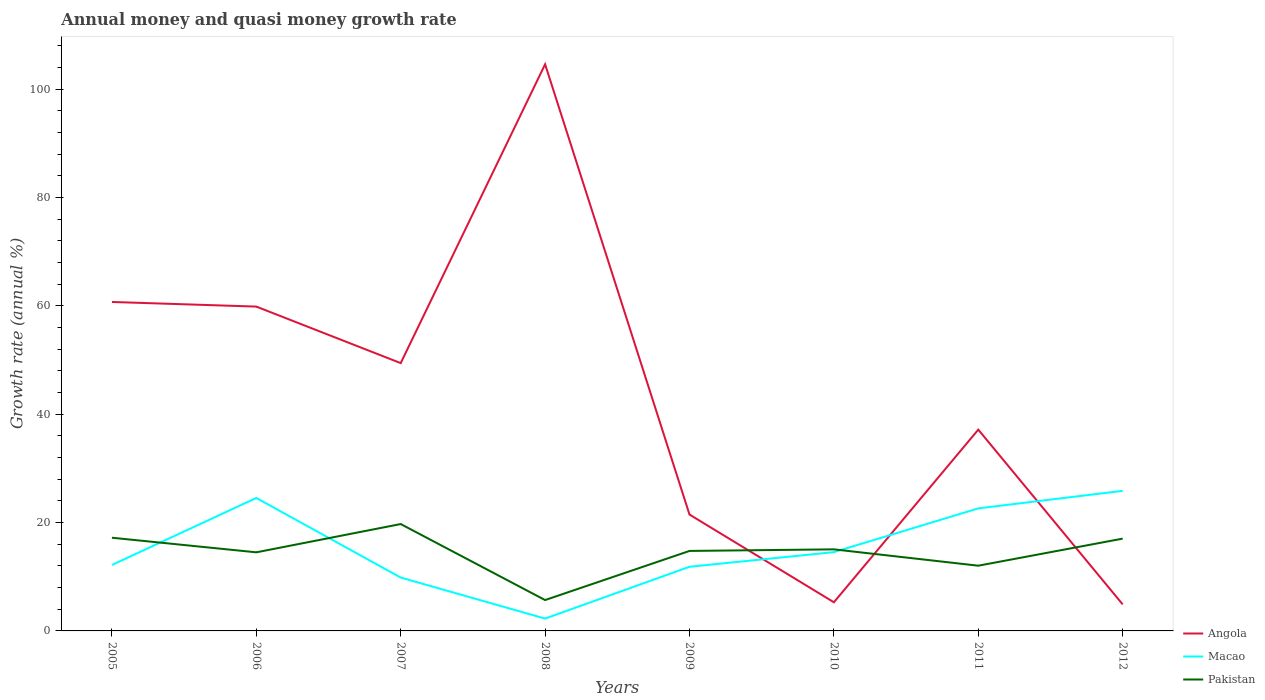Does the line corresponding to Macao intersect with the line corresponding to Pakistan?
Your answer should be compact. Yes. Is the number of lines equal to the number of legend labels?
Offer a terse response. Yes. Across all years, what is the maximum growth rate in Angola?
Your answer should be very brief. 4.9. In which year was the growth rate in Macao maximum?
Offer a very short reply. 2008. What is the total growth rate in Angola in the graph?
Provide a succinct answer. 10.43. What is the difference between the highest and the second highest growth rate in Pakistan?
Provide a short and direct response. 14.03. What is the difference between the highest and the lowest growth rate in Angola?
Ensure brevity in your answer.  4. Is the growth rate in Macao strictly greater than the growth rate in Angola over the years?
Your response must be concise. No. How many lines are there?
Your answer should be compact. 3. What is the difference between two consecutive major ticks on the Y-axis?
Provide a short and direct response. 20. Are the values on the major ticks of Y-axis written in scientific E-notation?
Offer a very short reply. No. What is the title of the graph?
Your answer should be compact. Annual money and quasi money growth rate. Does "Zambia" appear as one of the legend labels in the graph?
Keep it short and to the point. No. What is the label or title of the X-axis?
Keep it short and to the point. Years. What is the label or title of the Y-axis?
Your response must be concise. Growth rate (annual %). What is the Growth rate (annual %) of Angola in 2005?
Provide a succinct answer. 60.71. What is the Growth rate (annual %) of Macao in 2005?
Give a very brief answer. 12.17. What is the Growth rate (annual %) of Pakistan in 2005?
Ensure brevity in your answer.  17.2. What is the Growth rate (annual %) in Angola in 2006?
Your answer should be compact. 59.85. What is the Growth rate (annual %) of Macao in 2006?
Provide a succinct answer. 24.54. What is the Growth rate (annual %) of Pakistan in 2006?
Your answer should be very brief. 14.5. What is the Growth rate (annual %) of Angola in 2007?
Offer a very short reply. 49.42. What is the Growth rate (annual %) of Macao in 2007?
Offer a very short reply. 9.85. What is the Growth rate (annual %) in Pakistan in 2007?
Your answer should be very brief. 19.72. What is the Growth rate (annual %) in Angola in 2008?
Offer a very short reply. 104.57. What is the Growth rate (annual %) in Macao in 2008?
Your response must be concise. 2.28. What is the Growth rate (annual %) of Pakistan in 2008?
Provide a succinct answer. 5.69. What is the Growth rate (annual %) of Angola in 2009?
Your answer should be compact. 21.48. What is the Growth rate (annual %) of Macao in 2009?
Your answer should be compact. 11.84. What is the Growth rate (annual %) in Pakistan in 2009?
Give a very brief answer. 14.76. What is the Growth rate (annual %) of Angola in 2010?
Give a very brief answer. 5.29. What is the Growth rate (annual %) of Macao in 2010?
Provide a short and direct response. 14.54. What is the Growth rate (annual %) of Pakistan in 2010?
Keep it short and to the point. 15.05. What is the Growth rate (annual %) of Angola in 2011?
Your response must be concise. 37.15. What is the Growth rate (annual %) of Macao in 2011?
Offer a very short reply. 22.61. What is the Growth rate (annual %) in Pakistan in 2011?
Provide a short and direct response. 12.04. What is the Growth rate (annual %) of Angola in 2012?
Keep it short and to the point. 4.9. What is the Growth rate (annual %) of Macao in 2012?
Your answer should be compact. 25.85. What is the Growth rate (annual %) in Pakistan in 2012?
Make the answer very short. 17.03. Across all years, what is the maximum Growth rate (annual %) in Angola?
Ensure brevity in your answer.  104.57. Across all years, what is the maximum Growth rate (annual %) of Macao?
Ensure brevity in your answer.  25.85. Across all years, what is the maximum Growth rate (annual %) in Pakistan?
Provide a succinct answer. 19.72. Across all years, what is the minimum Growth rate (annual %) in Angola?
Provide a succinct answer. 4.9. Across all years, what is the minimum Growth rate (annual %) in Macao?
Make the answer very short. 2.28. Across all years, what is the minimum Growth rate (annual %) of Pakistan?
Keep it short and to the point. 5.69. What is the total Growth rate (annual %) of Angola in the graph?
Make the answer very short. 343.35. What is the total Growth rate (annual %) in Macao in the graph?
Your response must be concise. 123.68. What is the total Growth rate (annual %) of Pakistan in the graph?
Offer a terse response. 116. What is the difference between the Growth rate (annual %) in Angola in 2005 and that in 2006?
Provide a short and direct response. 0.86. What is the difference between the Growth rate (annual %) of Macao in 2005 and that in 2006?
Offer a very short reply. -12.37. What is the difference between the Growth rate (annual %) of Pakistan in 2005 and that in 2006?
Keep it short and to the point. 2.69. What is the difference between the Growth rate (annual %) in Angola in 2005 and that in 2007?
Your answer should be compact. 11.28. What is the difference between the Growth rate (annual %) of Macao in 2005 and that in 2007?
Your answer should be compact. 2.32. What is the difference between the Growth rate (annual %) of Pakistan in 2005 and that in 2007?
Your answer should be compact. -2.52. What is the difference between the Growth rate (annual %) of Angola in 2005 and that in 2008?
Provide a succinct answer. -43.86. What is the difference between the Growth rate (annual %) of Macao in 2005 and that in 2008?
Keep it short and to the point. 9.89. What is the difference between the Growth rate (annual %) of Pakistan in 2005 and that in 2008?
Provide a short and direct response. 11.5. What is the difference between the Growth rate (annual %) in Angola in 2005 and that in 2009?
Your answer should be compact. 39.23. What is the difference between the Growth rate (annual %) of Macao in 2005 and that in 2009?
Ensure brevity in your answer.  0.33. What is the difference between the Growth rate (annual %) of Pakistan in 2005 and that in 2009?
Provide a succinct answer. 2.44. What is the difference between the Growth rate (annual %) in Angola in 2005 and that in 2010?
Ensure brevity in your answer.  55.42. What is the difference between the Growth rate (annual %) in Macao in 2005 and that in 2010?
Provide a short and direct response. -2.37. What is the difference between the Growth rate (annual %) of Pakistan in 2005 and that in 2010?
Provide a short and direct response. 2.14. What is the difference between the Growth rate (annual %) in Angola in 2005 and that in 2011?
Make the answer very short. 23.56. What is the difference between the Growth rate (annual %) of Macao in 2005 and that in 2011?
Keep it short and to the point. -10.44. What is the difference between the Growth rate (annual %) in Pakistan in 2005 and that in 2011?
Provide a short and direct response. 5.16. What is the difference between the Growth rate (annual %) of Angola in 2005 and that in 2012?
Give a very brief answer. 55.81. What is the difference between the Growth rate (annual %) of Macao in 2005 and that in 2012?
Provide a short and direct response. -13.68. What is the difference between the Growth rate (annual %) in Pakistan in 2005 and that in 2012?
Ensure brevity in your answer.  0.17. What is the difference between the Growth rate (annual %) in Angola in 2006 and that in 2007?
Provide a succinct answer. 10.43. What is the difference between the Growth rate (annual %) in Macao in 2006 and that in 2007?
Provide a short and direct response. 14.69. What is the difference between the Growth rate (annual %) in Pakistan in 2006 and that in 2007?
Your answer should be compact. -5.22. What is the difference between the Growth rate (annual %) of Angola in 2006 and that in 2008?
Provide a short and direct response. -44.72. What is the difference between the Growth rate (annual %) of Macao in 2006 and that in 2008?
Keep it short and to the point. 22.26. What is the difference between the Growth rate (annual %) in Pakistan in 2006 and that in 2008?
Offer a very short reply. 8.81. What is the difference between the Growth rate (annual %) of Angola in 2006 and that in 2009?
Give a very brief answer. 38.38. What is the difference between the Growth rate (annual %) in Macao in 2006 and that in 2009?
Give a very brief answer. 12.7. What is the difference between the Growth rate (annual %) of Pakistan in 2006 and that in 2009?
Make the answer very short. -0.25. What is the difference between the Growth rate (annual %) in Angola in 2006 and that in 2010?
Make the answer very short. 54.56. What is the difference between the Growth rate (annual %) of Macao in 2006 and that in 2010?
Your answer should be very brief. 10. What is the difference between the Growth rate (annual %) of Pakistan in 2006 and that in 2010?
Give a very brief answer. -0.55. What is the difference between the Growth rate (annual %) in Angola in 2006 and that in 2011?
Your response must be concise. 22.7. What is the difference between the Growth rate (annual %) in Macao in 2006 and that in 2011?
Make the answer very short. 1.92. What is the difference between the Growth rate (annual %) of Pakistan in 2006 and that in 2011?
Your response must be concise. 2.47. What is the difference between the Growth rate (annual %) of Angola in 2006 and that in 2012?
Ensure brevity in your answer.  54.95. What is the difference between the Growth rate (annual %) of Macao in 2006 and that in 2012?
Offer a very short reply. -1.31. What is the difference between the Growth rate (annual %) of Pakistan in 2006 and that in 2012?
Offer a very short reply. -2.52. What is the difference between the Growth rate (annual %) in Angola in 2007 and that in 2008?
Your answer should be very brief. -55.14. What is the difference between the Growth rate (annual %) in Macao in 2007 and that in 2008?
Your answer should be compact. 7.57. What is the difference between the Growth rate (annual %) in Pakistan in 2007 and that in 2008?
Give a very brief answer. 14.03. What is the difference between the Growth rate (annual %) of Angola in 2007 and that in 2009?
Keep it short and to the point. 27.95. What is the difference between the Growth rate (annual %) in Macao in 2007 and that in 2009?
Your answer should be very brief. -1.99. What is the difference between the Growth rate (annual %) in Pakistan in 2007 and that in 2009?
Your response must be concise. 4.96. What is the difference between the Growth rate (annual %) in Angola in 2007 and that in 2010?
Make the answer very short. 44.13. What is the difference between the Growth rate (annual %) in Macao in 2007 and that in 2010?
Give a very brief answer. -4.69. What is the difference between the Growth rate (annual %) in Pakistan in 2007 and that in 2010?
Ensure brevity in your answer.  4.67. What is the difference between the Growth rate (annual %) in Angola in 2007 and that in 2011?
Provide a succinct answer. 12.27. What is the difference between the Growth rate (annual %) in Macao in 2007 and that in 2011?
Give a very brief answer. -12.76. What is the difference between the Growth rate (annual %) of Pakistan in 2007 and that in 2011?
Your response must be concise. 7.69. What is the difference between the Growth rate (annual %) of Angola in 2007 and that in 2012?
Your answer should be compact. 44.52. What is the difference between the Growth rate (annual %) in Macao in 2007 and that in 2012?
Your answer should be very brief. -16. What is the difference between the Growth rate (annual %) of Pakistan in 2007 and that in 2012?
Your response must be concise. 2.69. What is the difference between the Growth rate (annual %) of Angola in 2008 and that in 2009?
Your answer should be very brief. 83.09. What is the difference between the Growth rate (annual %) in Macao in 2008 and that in 2009?
Keep it short and to the point. -9.56. What is the difference between the Growth rate (annual %) of Pakistan in 2008 and that in 2009?
Ensure brevity in your answer.  -9.06. What is the difference between the Growth rate (annual %) of Angola in 2008 and that in 2010?
Provide a short and direct response. 99.28. What is the difference between the Growth rate (annual %) of Macao in 2008 and that in 2010?
Offer a very short reply. -12.26. What is the difference between the Growth rate (annual %) in Pakistan in 2008 and that in 2010?
Provide a short and direct response. -9.36. What is the difference between the Growth rate (annual %) in Angola in 2008 and that in 2011?
Your answer should be very brief. 67.42. What is the difference between the Growth rate (annual %) in Macao in 2008 and that in 2011?
Provide a succinct answer. -20.34. What is the difference between the Growth rate (annual %) of Pakistan in 2008 and that in 2011?
Your response must be concise. -6.34. What is the difference between the Growth rate (annual %) of Angola in 2008 and that in 2012?
Offer a very short reply. 99.67. What is the difference between the Growth rate (annual %) in Macao in 2008 and that in 2012?
Offer a very short reply. -23.57. What is the difference between the Growth rate (annual %) in Pakistan in 2008 and that in 2012?
Provide a short and direct response. -11.33. What is the difference between the Growth rate (annual %) of Angola in 2009 and that in 2010?
Make the answer very short. 16.19. What is the difference between the Growth rate (annual %) of Macao in 2009 and that in 2010?
Ensure brevity in your answer.  -2.7. What is the difference between the Growth rate (annual %) of Pakistan in 2009 and that in 2010?
Your answer should be very brief. -0.29. What is the difference between the Growth rate (annual %) in Angola in 2009 and that in 2011?
Offer a very short reply. -15.67. What is the difference between the Growth rate (annual %) of Macao in 2009 and that in 2011?
Offer a very short reply. -10.77. What is the difference between the Growth rate (annual %) in Pakistan in 2009 and that in 2011?
Offer a very short reply. 2.72. What is the difference between the Growth rate (annual %) in Angola in 2009 and that in 2012?
Offer a very short reply. 16.58. What is the difference between the Growth rate (annual %) in Macao in 2009 and that in 2012?
Keep it short and to the point. -14.01. What is the difference between the Growth rate (annual %) in Pakistan in 2009 and that in 2012?
Provide a short and direct response. -2.27. What is the difference between the Growth rate (annual %) of Angola in 2010 and that in 2011?
Your answer should be very brief. -31.86. What is the difference between the Growth rate (annual %) in Macao in 2010 and that in 2011?
Your answer should be compact. -8.07. What is the difference between the Growth rate (annual %) of Pakistan in 2010 and that in 2011?
Offer a terse response. 3.02. What is the difference between the Growth rate (annual %) of Angola in 2010 and that in 2012?
Make the answer very short. 0.39. What is the difference between the Growth rate (annual %) in Macao in 2010 and that in 2012?
Provide a short and direct response. -11.31. What is the difference between the Growth rate (annual %) in Pakistan in 2010 and that in 2012?
Offer a terse response. -1.98. What is the difference between the Growth rate (annual %) of Angola in 2011 and that in 2012?
Offer a very short reply. 32.25. What is the difference between the Growth rate (annual %) of Macao in 2011 and that in 2012?
Make the answer very short. -3.24. What is the difference between the Growth rate (annual %) of Pakistan in 2011 and that in 2012?
Your response must be concise. -4.99. What is the difference between the Growth rate (annual %) in Angola in 2005 and the Growth rate (annual %) in Macao in 2006?
Offer a terse response. 36.17. What is the difference between the Growth rate (annual %) in Angola in 2005 and the Growth rate (annual %) in Pakistan in 2006?
Your answer should be very brief. 46.2. What is the difference between the Growth rate (annual %) of Macao in 2005 and the Growth rate (annual %) of Pakistan in 2006?
Offer a terse response. -2.33. What is the difference between the Growth rate (annual %) of Angola in 2005 and the Growth rate (annual %) of Macao in 2007?
Your response must be concise. 50.86. What is the difference between the Growth rate (annual %) in Angola in 2005 and the Growth rate (annual %) in Pakistan in 2007?
Make the answer very short. 40.98. What is the difference between the Growth rate (annual %) of Macao in 2005 and the Growth rate (annual %) of Pakistan in 2007?
Offer a very short reply. -7.55. What is the difference between the Growth rate (annual %) in Angola in 2005 and the Growth rate (annual %) in Macao in 2008?
Offer a terse response. 58.43. What is the difference between the Growth rate (annual %) in Angola in 2005 and the Growth rate (annual %) in Pakistan in 2008?
Offer a terse response. 55.01. What is the difference between the Growth rate (annual %) of Macao in 2005 and the Growth rate (annual %) of Pakistan in 2008?
Ensure brevity in your answer.  6.48. What is the difference between the Growth rate (annual %) in Angola in 2005 and the Growth rate (annual %) in Macao in 2009?
Provide a short and direct response. 48.87. What is the difference between the Growth rate (annual %) of Angola in 2005 and the Growth rate (annual %) of Pakistan in 2009?
Offer a terse response. 45.95. What is the difference between the Growth rate (annual %) of Macao in 2005 and the Growth rate (annual %) of Pakistan in 2009?
Offer a terse response. -2.59. What is the difference between the Growth rate (annual %) in Angola in 2005 and the Growth rate (annual %) in Macao in 2010?
Make the answer very short. 46.17. What is the difference between the Growth rate (annual %) of Angola in 2005 and the Growth rate (annual %) of Pakistan in 2010?
Your answer should be compact. 45.65. What is the difference between the Growth rate (annual %) of Macao in 2005 and the Growth rate (annual %) of Pakistan in 2010?
Your answer should be compact. -2.88. What is the difference between the Growth rate (annual %) of Angola in 2005 and the Growth rate (annual %) of Macao in 2011?
Ensure brevity in your answer.  38.09. What is the difference between the Growth rate (annual %) in Angola in 2005 and the Growth rate (annual %) in Pakistan in 2011?
Provide a short and direct response. 48.67. What is the difference between the Growth rate (annual %) in Macao in 2005 and the Growth rate (annual %) in Pakistan in 2011?
Ensure brevity in your answer.  0.13. What is the difference between the Growth rate (annual %) of Angola in 2005 and the Growth rate (annual %) of Macao in 2012?
Give a very brief answer. 34.85. What is the difference between the Growth rate (annual %) in Angola in 2005 and the Growth rate (annual %) in Pakistan in 2012?
Ensure brevity in your answer.  43.68. What is the difference between the Growth rate (annual %) of Macao in 2005 and the Growth rate (annual %) of Pakistan in 2012?
Your response must be concise. -4.86. What is the difference between the Growth rate (annual %) in Angola in 2006 and the Growth rate (annual %) in Macao in 2007?
Provide a succinct answer. 50. What is the difference between the Growth rate (annual %) of Angola in 2006 and the Growth rate (annual %) of Pakistan in 2007?
Give a very brief answer. 40.13. What is the difference between the Growth rate (annual %) in Macao in 2006 and the Growth rate (annual %) in Pakistan in 2007?
Offer a terse response. 4.81. What is the difference between the Growth rate (annual %) in Angola in 2006 and the Growth rate (annual %) in Macao in 2008?
Your answer should be compact. 57.57. What is the difference between the Growth rate (annual %) of Angola in 2006 and the Growth rate (annual %) of Pakistan in 2008?
Make the answer very short. 54.16. What is the difference between the Growth rate (annual %) in Macao in 2006 and the Growth rate (annual %) in Pakistan in 2008?
Make the answer very short. 18.84. What is the difference between the Growth rate (annual %) of Angola in 2006 and the Growth rate (annual %) of Macao in 2009?
Make the answer very short. 48.01. What is the difference between the Growth rate (annual %) in Angola in 2006 and the Growth rate (annual %) in Pakistan in 2009?
Offer a very short reply. 45.09. What is the difference between the Growth rate (annual %) in Macao in 2006 and the Growth rate (annual %) in Pakistan in 2009?
Offer a terse response. 9.78. What is the difference between the Growth rate (annual %) of Angola in 2006 and the Growth rate (annual %) of Macao in 2010?
Offer a very short reply. 45.31. What is the difference between the Growth rate (annual %) of Angola in 2006 and the Growth rate (annual %) of Pakistan in 2010?
Your response must be concise. 44.8. What is the difference between the Growth rate (annual %) of Macao in 2006 and the Growth rate (annual %) of Pakistan in 2010?
Provide a short and direct response. 9.48. What is the difference between the Growth rate (annual %) in Angola in 2006 and the Growth rate (annual %) in Macao in 2011?
Your answer should be very brief. 37.24. What is the difference between the Growth rate (annual %) of Angola in 2006 and the Growth rate (annual %) of Pakistan in 2011?
Your response must be concise. 47.81. What is the difference between the Growth rate (annual %) in Angola in 2006 and the Growth rate (annual %) in Macao in 2012?
Keep it short and to the point. 34. What is the difference between the Growth rate (annual %) in Angola in 2006 and the Growth rate (annual %) in Pakistan in 2012?
Your response must be concise. 42.82. What is the difference between the Growth rate (annual %) of Macao in 2006 and the Growth rate (annual %) of Pakistan in 2012?
Provide a succinct answer. 7.51. What is the difference between the Growth rate (annual %) of Angola in 2007 and the Growth rate (annual %) of Macao in 2008?
Your response must be concise. 47.14. What is the difference between the Growth rate (annual %) in Angola in 2007 and the Growth rate (annual %) in Pakistan in 2008?
Provide a short and direct response. 43.73. What is the difference between the Growth rate (annual %) of Macao in 2007 and the Growth rate (annual %) of Pakistan in 2008?
Keep it short and to the point. 4.15. What is the difference between the Growth rate (annual %) of Angola in 2007 and the Growth rate (annual %) of Macao in 2009?
Offer a terse response. 37.58. What is the difference between the Growth rate (annual %) of Angola in 2007 and the Growth rate (annual %) of Pakistan in 2009?
Give a very brief answer. 34.66. What is the difference between the Growth rate (annual %) of Macao in 2007 and the Growth rate (annual %) of Pakistan in 2009?
Ensure brevity in your answer.  -4.91. What is the difference between the Growth rate (annual %) in Angola in 2007 and the Growth rate (annual %) in Macao in 2010?
Make the answer very short. 34.88. What is the difference between the Growth rate (annual %) in Angola in 2007 and the Growth rate (annual %) in Pakistan in 2010?
Provide a short and direct response. 34.37. What is the difference between the Growth rate (annual %) in Macao in 2007 and the Growth rate (annual %) in Pakistan in 2010?
Offer a terse response. -5.21. What is the difference between the Growth rate (annual %) of Angola in 2007 and the Growth rate (annual %) of Macao in 2011?
Your answer should be very brief. 26.81. What is the difference between the Growth rate (annual %) of Angola in 2007 and the Growth rate (annual %) of Pakistan in 2011?
Your response must be concise. 37.38. What is the difference between the Growth rate (annual %) of Macao in 2007 and the Growth rate (annual %) of Pakistan in 2011?
Offer a terse response. -2.19. What is the difference between the Growth rate (annual %) of Angola in 2007 and the Growth rate (annual %) of Macao in 2012?
Your answer should be compact. 23.57. What is the difference between the Growth rate (annual %) in Angola in 2007 and the Growth rate (annual %) in Pakistan in 2012?
Offer a very short reply. 32.39. What is the difference between the Growth rate (annual %) in Macao in 2007 and the Growth rate (annual %) in Pakistan in 2012?
Provide a succinct answer. -7.18. What is the difference between the Growth rate (annual %) in Angola in 2008 and the Growth rate (annual %) in Macao in 2009?
Your response must be concise. 92.73. What is the difference between the Growth rate (annual %) of Angola in 2008 and the Growth rate (annual %) of Pakistan in 2009?
Your response must be concise. 89.81. What is the difference between the Growth rate (annual %) of Macao in 2008 and the Growth rate (annual %) of Pakistan in 2009?
Ensure brevity in your answer.  -12.48. What is the difference between the Growth rate (annual %) in Angola in 2008 and the Growth rate (annual %) in Macao in 2010?
Keep it short and to the point. 90.03. What is the difference between the Growth rate (annual %) of Angola in 2008 and the Growth rate (annual %) of Pakistan in 2010?
Offer a very short reply. 89.51. What is the difference between the Growth rate (annual %) in Macao in 2008 and the Growth rate (annual %) in Pakistan in 2010?
Provide a succinct answer. -12.78. What is the difference between the Growth rate (annual %) of Angola in 2008 and the Growth rate (annual %) of Macao in 2011?
Your response must be concise. 81.95. What is the difference between the Growth rate (annual %) of Angola in 2008 and the Growth rate (annual %) of Pakistan in 2011?
Offer a terse response. 92.53. What is the difference between the Growth rate (annual %) in Macao in 2008 and the Growth rate (annual %) in Pakistan in 2011?
Keep it short and to the point. -9.76. What is the difference between the Growth rate (annual %) of Angola in 2008 and the Growth rate (annual %) of Macao in 2012?
Offer a terse response. 78.71. What is the difference between the Growth rate (annual %) of Angola in 2008 and the Growth rate (annual %) of Pakistan in 2012?
Your answer should be very brief. 87.54. What is the difference between the Growth rate (annual %) in Macao in 2008 and the Growth rate (annual %) in Pakistan in 2012?
Your answer should be compact. -14.75. What is the difference between the Growth rate (annual %) in Angola in 2009 and the Growth rate (annual %) in Macao in 2010?
Make the answer very short. 6.94. What is the difference between the Growth rate (annual %) of Angola in 2009 and the Growth rate (annual %) of Pakistan in 2010?
Provide a short and direct response. 6.42. What is the difference between the Growth rate (annual %) of Macao in 2009 and the Growth rate (annual %) of Pakistan in 2010?
Provide a succinct answer. -3.21. What is the difference between the Growth rate (annual %) of Angola in 2009 and the Growth rate (annual %) of Macao in 2011?
Keep it short and to the point. -1.14. What is the difference between the Growth rate (annual %) in Angola in 2009 and the Growth rate (annual %) in Pakistan in 2011?
Offer a terse response. 9.44. What is the difference between the Growth rate (annual %) of Macao in 2009 and the Growth rate (annual %) of Pakistan in 2011?
Provide a succinct answer. -0.2. What is the difference between the Growth rate (annual %) in Angola in 2009 and the Growth rate (annual %) in Macao in 2012?
Your response must be concise. -4.38. What is the difference between the Growth rate (annual %) of Angola in 2009 and the Growth rate (annual %) of Pakistan in 2012?
Offer a very short reply. 4.45. What is the difference between the Growth rate (annual %) of Macao in 2009 and the Growth rate (annual %) of Pakistan in 2012?
Offer a very short reply. -5.19. What is the difference between the Growth rate (annual %) in Angola in 2010 and the Growth rate (annual %) in Macao in 2011?
Ensure brevity in your answer.  -17.32. What is the difference between the Growth rate (annual %) of Angola in 2010 and the Growth rate (annual %) of Pakistan in 2011?
Your answer should be compact. -6.75. What is the difference between the Growth rate (annual %) of Macao in 2010 and the Growth rate (annual %) of Pakistan in 2011?
Give a very brief answer. 2.5. What is the difference between the Growth rate (annual %) of Angola in 2010 and the Growth rate (annual %) of Macao in 2012?
Your answer should be very brief. -20.56. What is the difference between the Growth rate (annual %) in Angola in 2010 and the Growth rate (annual %) in Pakistan in 2012?
Ensure brevity in your answer.  -11.74. What is the difference between the Growth rate (annual %) of Macao in 2010 and the Growth rate (annual %) of Pakistan in 2012?
Your response must be concise. -2.49. What is the difference between the Growth rate (annual %) in Angola in 2011 and the Growth rate (annual %) in Macao in 2012?
Provide a succinct answer. 11.3. What is the difference between the Growth rate (annual %) in Angola in 2011 and the Growth rate (annual %) in Pakistan in 2012?
Offer a very short reply. 20.12. What is the difference between the Growth rate (annual %) in Macao in 2011 and the Growth rate (annual %) in Pakistan in 2012?
Your answer should be compact. 5.58. What is the average Growth rate (annual %) in Angola per year?
Your response must be concise. 42.92. What is the average Growth rate (annual %) of Macao per year?
Your answer should be very brief. 15.46. What is the average Growth rate (annual %) of Pakistan per year?
Your answer should be compact. 14.5. In the year 2005, what is the difference between the Growth rate (annual %) of Angola and Growth rate (annual %) of Macao?
Your answer should be very brief. 48.54. In the year 2005, what is the difference between the Growth rate (annual %) of Angola and Growth rate (annual %) of Pakistan?
Give a very brief answer. 43.51. In the year 2005, what is the difference between the Growth rate (annual %) in Macao and Growth rate (annual %) in Pakistan?
Your answer should be very brief. -5.03. In the year 2006, what is the difference between the Growth rate (annual %) in Angola and Growth rate (annual %) in Macao?
Keep it short and to the point. 35.31. In the year 2006, what is the difference between the Growth rate (annual %) in Angola and Growth rate (annual %) in Pakistan?
Ensure brevity in your answer.  45.35. In the year 2006, what is the difference between the Growth rate (annual %) in Macao and Growth rate (annual %) in Pakistan?
Keep it short and to the point. 10.03. In the year 2007, what is the difference between the Growth rate (annual %) of Angola and Growth rate (annual %) of Macao?
Your response must be concise. 39.57. In the year 2007, what is the difference between the Growth rate (annual %) in Angola and Growth rate (annual %) in Pakistan?
Provide a short and direct response. 29.7. In the year 2007, what is the difference between the Growth rate (annual %) in Macao and Growth rate (annual %) in Pakistan?
Offer a very short reply. -9.87. In the year 2008, what is the difference between the Growth rate (annual %) of Angola and Growth rate (annual %) of Macao?
Provide a short and direct response. 102.29. In the year 2008, what is the difference between the Growth rate (annual %) of Angola and Growth rate (annual %) of Pakistan?
Provide a short and direct response. 98.87. In the year 2008, what is the difference between the Growth rate (annual %) in Macao and Growth rate (annual %) in Pakistan?
Offer a very short reply. -3.42. In the year 2009, what is the difference between the Growth rate (annual %) in Angola and Growth rate (annual %) in Macao?
Your answer should be compact. 9.64. In the year 2009, what is the difference between the Growth rate (annual %) of Angola and Growth rate (annual %) of Pakistan?
Your response must be concise. 6.72. In the year 2009, what is the difference between the Growth rate (annual %) in Macao and Growth rate (annual %) in Pakistan?
Your answer should be very brief. -2.92. In the year 2010, what is the difference between the Growth rate (annual %) of Angola and Growth rate (annual %) of Macao?
Provide a short and direct response. -9.25. In the year 2010, what is the difference between the Growth rate (annual %) in Angola and Growth rate (annual %) in Pakistan?
Offer a terse response. -9.77. In the year 2010, what is the difference between the Growth rate (annual %) in Macao and Growth rate (annual %) in Pakistan?
Keep it short and to the point. -0.51. In the year 2011, what is the difference between the Growth rate (annual %) of Angola and Growth rate (annual %) of Macao?
Make the answer very short. 14.53. In the year 2011, what is the difference between the Growth rate (annual %) of Angola and Growth rate (annual %) of Pakistan?
Your answer should be very brief. 25.11. In the year 2011, what is the difference between the Growth rate (annual %) of Macao and Growth rate (annual %) of Pakistan?
Provide a succinct answer. 10.58. In the year 2012, what is the difference between the Growth rate (annual %) of Angola and Growth rate (annual %) of Macao?
Your answer should be compact. -20.95. In the year 2012, what is the difference between the Growth rate (annual %) in Angola and Growth rate (annual %) in Pakistan?
Offer a terse response. -12.13. In the year 2012, what is the difference between the Growth rate (annual %) of Macao and Growth rate (annual %) of Pakistan?
Offer a very short reply. 8.82. What is the ratio of the Growth rate (annual %) in Angola in 2005 to that in 2006?
Your answer should be compact. 1.01. What is the ratio of the Growth rate (annual %) of Macao in 2005 to that in 2006?
Make the answer very short. 0.5. What is the ratio of the Growth rate (annual %) of Pakistan in 2005 to that in 2006?
Keep it short and to the point. 1.19. What is the ratio of the Growth rate (annual %) of Angola in 2005 to that in 2007?
Give a very brief answer. 1.23. What is the ratio of the Growth rate (annual %) in Macao in 2005 to that in 2007?
Give a very brief answer. 1.24. What is the ratio of the Growth rate (annual %) in Pakistan in 2005 to that in 2007?
Provide a succinct answer. 0.87. What is the ratio of the Growth rate (annual %) in Angola in 2005 to that in 2008?
Keep it short and to the point. 0.58. What is the ratio of the Growth rate (annual %) of Macao in 2005 to that in 2008?
Your response must be concise. 5.35. What is the ratio of the Growth rate (annual %) of Pakistan in 2005 to that in 2008?
Make the answer very short. 3.02. What is the ratio of the Growth rate (annual %) in Angola in 2005 to that in 2009?
Make the answer very short. 2.83. What is the ratio of the Growth rate (annual %) of Macao in 2005 to that in 2009?
Your response must be concise. 1.03. What is the ratio of the Growth rate (annual %) in Pakistan in 2005 to that in 2009?
Your response must be concise. 1.17. What is the ratio of the Growth rate (annual %) of Angola in 2005 to that in 2010?
Your response must be concise. 11.48. What is the ratio of the Growth rate (annual %) of Macao in 2005 to that in 2010?
Give a very brief answer. 0.84. What is the ratio of the Growth rate (annual %) of Pakistan in 2005 to that in 2010?
Provide a succinct answer. 1.14. What is the ratio of the Growth rate (annual %) of Angola in 2005 to that in 2011?
Provide a short and direct response. 1.63. What is the ratio of the Growth rate (annual %) in Macao in 2005 to that in 2011?
Keep it short and to the point. 0.54. What is the ratio of the Growth rate (annual %) in Pakistan in 2005 to that in 2011?
Provide a short and direct response. 1.43. What is the ratio of the Growth rate (annual %) in Angola in 2005 to that in 2012?
Offer a very short reply. 12.39. What is the ratio of the Growth rate (annual %) in Macao in 2005 to that in 2012?
Keep it short and to the point. 0.47. What is the ratio of the Growth rate (annual %) in Pakistan in 2005 to that in 2012?
Ensure brevity in your answer.  1.01. What is the ratio of the Growth rate (annual %) in Angola in 2006 to that in 2007?
Give a very brief answer. 1.21. What is the ratio of the Growth rate (annual %) of Macao in 2006 to that in 2007?
Your answer should be compact. 2.49. What is the ratio of the Growth rate (annual %) in Pakistan in 2006 to that in 2007?
Ensure brevity in your answer.  0.74. What is the ratio of the Growth rate (annual %) in Angola in 2006 to that in 2008?
Offer a very short reply. 0.57. What is the ratio of the Growth rate (annual %) in Macao in 2006 to that in 2008?
Offer a terse response. 10.78. What is the ratio of the Growth rate (annual %) of Pakistan in 2006 to that in 2008?
Give a very brief answer. 2.55. What is the ratio of the Growth rate (annual %) in Angola in 2006 to that in 2009?
Ensure brevity in your answer.  2.79. What is the ratio of the Growth rate (annual %) in Macao in 2006 to that in 2009?
Your response must be concise. 2.07. What is the ratio of the Growth rate (annual %) in Pakistan in 2006 to that in 2009?
Give a very brief answer. 0.98. What is the ratio of the Growth rate (annual %) in Angola in 2006 to that in 2010?
Ensure brevity in your answer.  11.32. What is the ratio of the Growth rate (annual %) in Macao in 2006 to that in 2010?
Offer a terse response. 1.69. What is the ratio of the Growth rate (annual %) of Pakistan in 2006 to that in 2010?
Provide a succinct answer. 0.96. What is the ratio of the Growth rate (annual %) of Angola in 2006 to that in 2011?
Give a very brief answer. 1.61. What is the ratio of the Growth rate (annual %) in Macao in 2006 to that in 2011?
Your answer should be very brief. 1.09. What is the ratio of the Growth rate (annual %) of Pakistan in 2006 to that in 2011?
Offer a terse response. 1.21. What is the ratio of the Growth rate (annual %) in Angola in 2006 to that in 2012?
Give a very brief answer. 12.22. What is the ratio of the Growth rate (annual %) of Macao in 2006 to that in 2012?
Provide a succinct answer. 0.95. What is the ratio of the Growth rate (annual %) in Pakistan in 2006 to that in 2012?
Make the answer very short. 0.85. What is the ratio of the Growth rate (annual %) of Angola in 2007 to that in 2008?
Provide a succinct answer. 0.47. What is the ratio of the Growth rate (annual %) of Macao in 2007 to that in 2008?
Provide a short and direct response. 4.33. What is the ratio of the Growth rate (annual %) in Pakistan in 2007 to that in 2008?
Offer a terse response. 3.46. What is the ratio of the Growth rate (annual %) of Angola in 2007 to that in 2009?
Make the answer very short. 2.3. What is the ratio of the Growth rate (annual %) in Macao in 2007 to that in 2009?
Ensure brevity in your answer.  0.83. What is the ratio of the Growth rate (annual %) of Pakistan in 2007 to that in 2009?
Offer a terse response. 1.34. What is the ratio of the Growth rate (annual %) in Angola in 2007 to that in 2010?
Make the answer very short. 9.35. What is the ratio of the Growth rate (annual %) in Macao in 2007 to that in 2010?
Keep it short and to the point. 0.68. What is the ratio of the Growth rate (annual %) of Pakistan in 2007 to that in 2010?
Offer a terse response. 1.31. What is the ratio of the Growth rate (annual %) of Angola in 2007 to that in 2011?
Provide a short and direct response. 1.33. What is the ratio of the Growth rate (annual %) in Macao in 2007 to that in 2011?
Offer a very short reply. 0.44. What is the ratio of the Growth rate (annual %) of Pakistan in 2007 to that in 2011?
Provide a short and direct response. 1.64. What is the ratio of the Growth rate (annual %) of Angola in 2007 to that in 2012?
Provide a short and direct response. 10.09. What is the ratio of the Growth rate (annual %) of Macao in 2007 to that in 2012?
Your response must be concise. 0.38. What is the ratio of the Growth rate (annual %) in Pakistan in 2007 to that in 2012?
Make the answer very short. 1.16. What is the ratio of the Growth rate (annual %) in Angola in 2008 to that in 2009?
Offer a terse response. 4.87. What is the ratio of the Growth rate (annual %) of Macao in 2008 to that in 2009?
Make the answer very short. 0.19. What is the ratio of the Growth rate (annual %) of Pakistan in 2008 to that in 2009?
Ensure brevity in your answer.  0.39. What is the ratio of the Growth rate (annual %) of Angola in 2008 to that in 2010?
Provide a short and direct response. 19.77. What is the ratio of the Growth rate (annual %) in Macao in 2008 to that in 2010?
Ensure brevity in your answer.  0.16. What is the ratio of the Growth rate (annual %) in Pakistan in 2008 to that in 2010?
Offer a terse response. 0.38. What is the ratio of the Growth rate (annual %) in Angola in 2008 to that in 2011?
Keep it short and to the point. 2.81. What is the ratio of the Growth rate (annual %) of Macao in 2008 to that in 2011?
Provide a succinct answer. 0.1. What is the ratio of the Growth rate (annual %) in Pakistan in 2008 to that in 2011?
Make the answer very short. 0.47. What is the ratio of the Growth rate (annual %) in Angola in 2008 to that in 2012?
Make the answer very short. 21.35. What is the ratio of the Growth rate (annual %) in Macao in 2008 to that in 2012?
Keep it short and to the point. 0.09. What is the ratio of the Growth rate (annual %) of Pakistan in 2008 to that in 2012?
Your answer should be compact. 0.33. What is the ratio of the Growth rate (annual %) of Angola in 2009 to that in 2010?
Your response must be concise. 4.06. What is the ratio of the Growth rate (annual %) in Macao in 2009 to that in 2010?
Keep it short and to the point. 0.81. What is the ratio of the Growth rate (annual %) in Pakistan in 2009 to that in 2010?
Ensure brevity in your answer.  0.98. What is the ratio of the Growth rate (annual %) of Angola in 2009 to that in 2011?
Give a very brief answer. 0.58. What is the ratio of the Growth rate (annual %) in Macao in 2009 to that in 2011?
Your response must be concise. 0.52. What is the ratio of the Growth rate (annual %) of Pakistan in 2009 to that in 2011?
Provide a short and direct response. 1.23. What is the ratio of the Growth rate (annual %) in Angola in 2009 to that in 2012?
Your answer should be compact. 4.38. What is the ratio of the Growth rate (annual %) in Macao in 2009 to that in 2012?
Give a very brief answer. 0.46. What is the ratio of the Growth rate (annual %) in Pakistan in 2009 to that in 2012?
Provide a short and direct response. 0.87. What is the ratio of the Growth rate (annual %) of Angola in 2010 to that in 2011?
Offer a very short reply. 0.14. What is the ratio of the Growth rate (annual %) of Macao in 2010 to that in 2011?
Give a very brief answer. 0.64. What is the ratio of the Growth rate (annual %) of Pakistan in 2010 to that in 2011?
Offer a very short reply. 1.25. What is the ratio of the Growth rate (annual %) in Angola in 2010 to that in 2012?
Keep it short and to the point. 1.08. What is the ratio of the Growth rate (annual %) in Macao in 2010 to that in 2012?
Offer a very short reply. 0.56. What is the ratio of the Growth rate (annual %) in Pakistan in 2010 to that in 2012?
Give a very brief answer. 0.88. What is the ratio of the Growth rate (annual %) of Angola in 2011 to that in 2012?
Your answer should be very brief. 7.58. What is the ratio of the Growth rate (annual %) of Macao in 2011 to that in 2012?
Your answer should be very brief. 0.87. What is the ratio of the Growth rate (annual %) in Pakistan in 2011 to that in 2012?
Your answer should be very brief. 0.71. What is the difference between the highest and the second highest Growth rate (annual %) of Angola?
Your answer should be compact. 43.86. What is the difference between the highest and the second highest Growth rate (annual %) in Macao?
Make the answer very short. 1.31. What is the difference between the highest and the second highest Growth rate (annual %) of Pakistan?
Give a very brief answer. 2.52. What is the difference between the highest and the lowest Growth rate (annual %) of Angola?
Make the answer very short. 99.67. What is the difference between the highest and the lowest Growth rate (annual %) of Macao?
Give a very brief answer. 23.57. What is the difference between the highest and the lowest Growth rate (annual %) in Pakistan?
Your response must be concise. 14.03. 